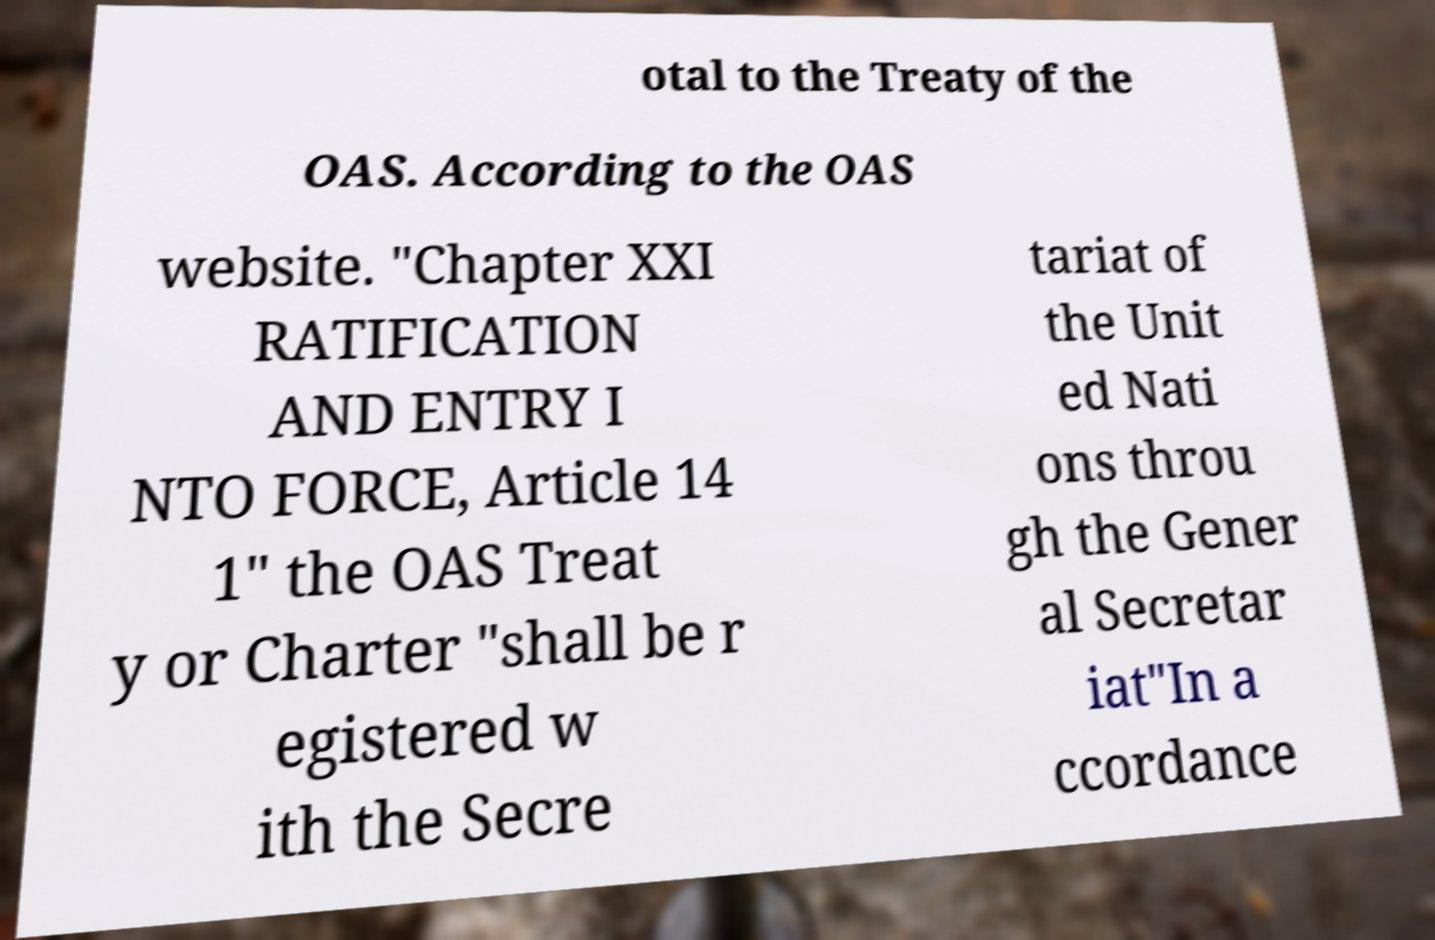Can you read and provide the text displayed in the image?This photo seems to have some interesting text. Can you extract and type it out for me? otal to the Treaty of the OAS. According to the OAS website. "Chapter XXI RATIFICATION AND ENTRY I NTO FORCE, Article 14 1" the OAS Treat y or Charter "shall be r egistered w ith the Secre tariat of the Unit ed Nati ons throu gh the Gener al Secretar iat"In a ccordance 